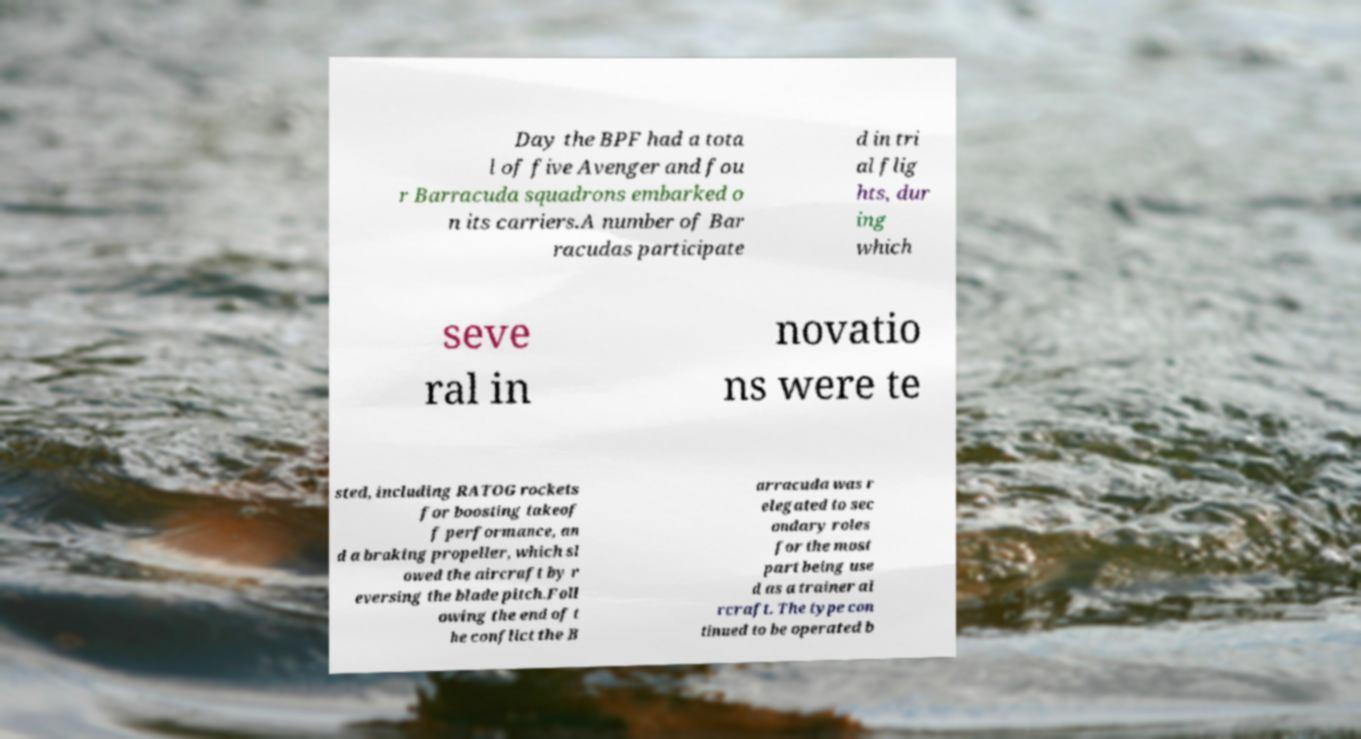Please read and relay the text visible in this image. What does it say? Day the BPF had a tota l of five Avenger and fou r Barracuda squadrons embarked o n its carriers.A number of Bar racudas participate d in tri al flig hts, dur ing which seve ral in novatio ns were te sted, including RATOG rockets for boosting takeof f performance, an d a braking propeller, which sl owed the aircraft by r eversing the blade pitch.Foll owing the end of t he conflict the B arracuda was r elegated to sec ondary roles for the most part being use d as a trainer ai rcraft. The type con tinued to be operated b 